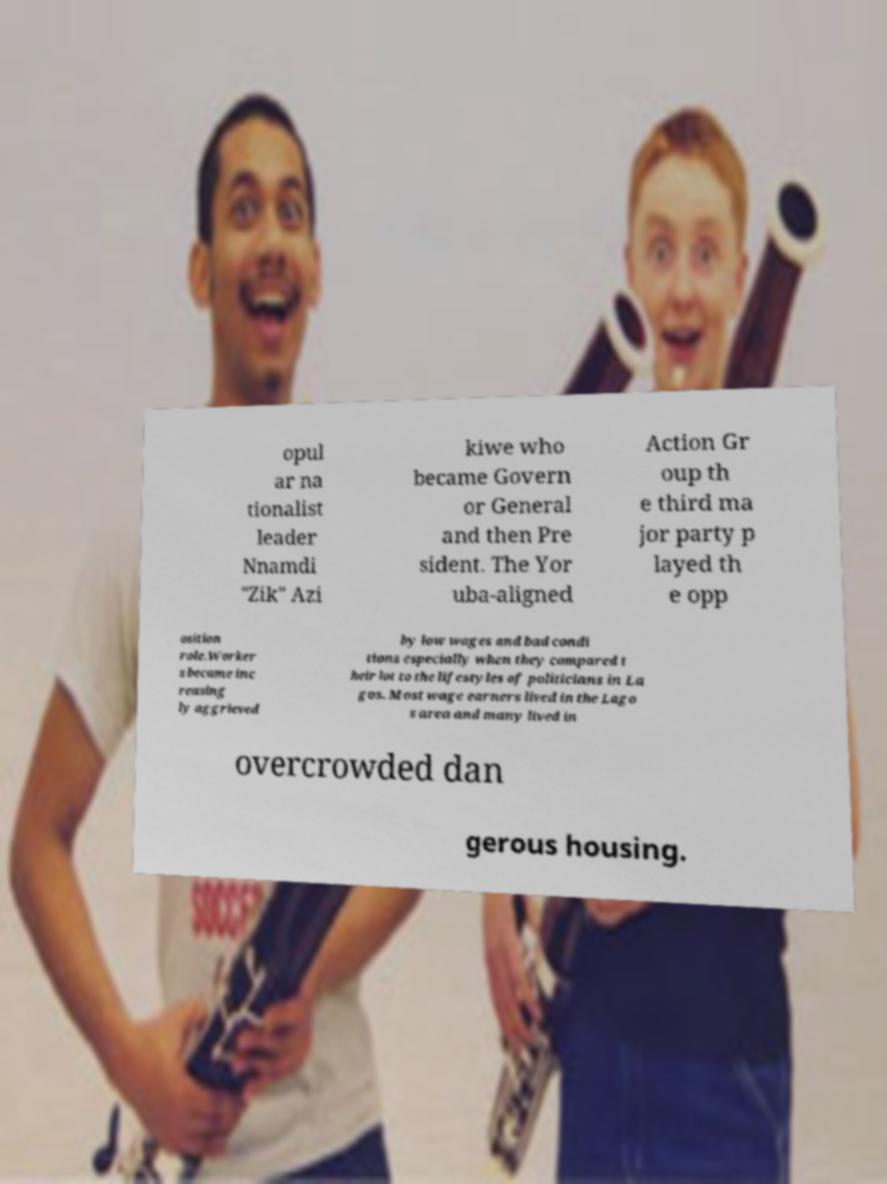Could you assist in decoding the text presented in this image and type it out clearly? opul ar na tionalist leader Nnamdi "Zik" Azi kiwe who became Govern or General and then Pre sident. The Yor uba-aligned Action Gr oup th e third ma jor party p layed th e opp osition role.Worker s became inc reasing ly aggrieved by low wages and bad condi tions especially when they compared t heir lot to the lifestyles of politicians in La gos. Most wage earners lived in the Lago s area and many lived in overcrowded dan gerous housing. 